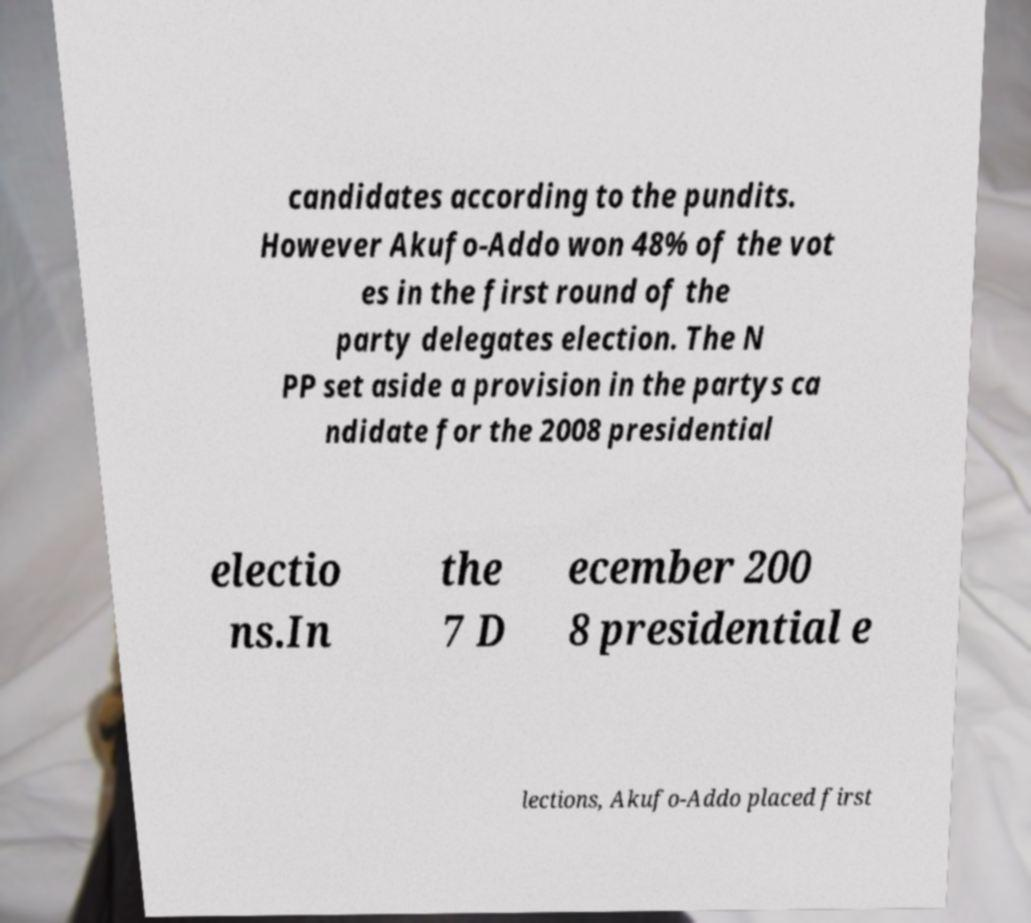For documentation purposes, I need the text within this image transcribed. Could you provide that? candidates according to the pundits. However Akufo-Addo won 48% of the vot es in the first round of the party delegates election. The N PP set aside a provision in the partys ca ndidate for the 2008 presidential electio ns.In the 7 D ecember 200 8 presidential e lections, Akufo-Addo placed first 